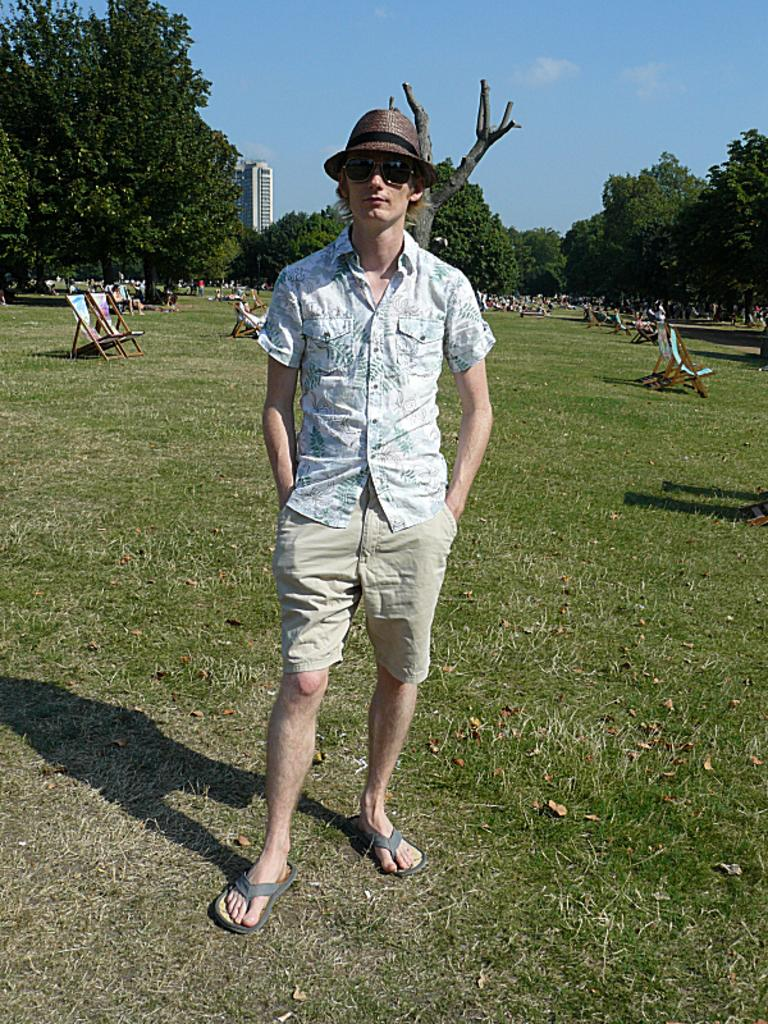What is the main subject of the image? There is a man standing in the image. Can you describe what the man is wearing? The man is wearing clothes, slippers, goggles, and a cap. What type of furniture can be seen in the image? There are rest chairs visible in the image. What type of natural elements are present in the image? There are trees in the image. What type of structure is visible in the image? There is a building in the image. What part of the natural environment is visible in the image? The sky is visible in the image. How many crates are stacked next to the man in the image? There are no crates present in the image. What type of bells can be heard ringing in the image? There are no bells present in the image, and therefore no sound can be heard. 